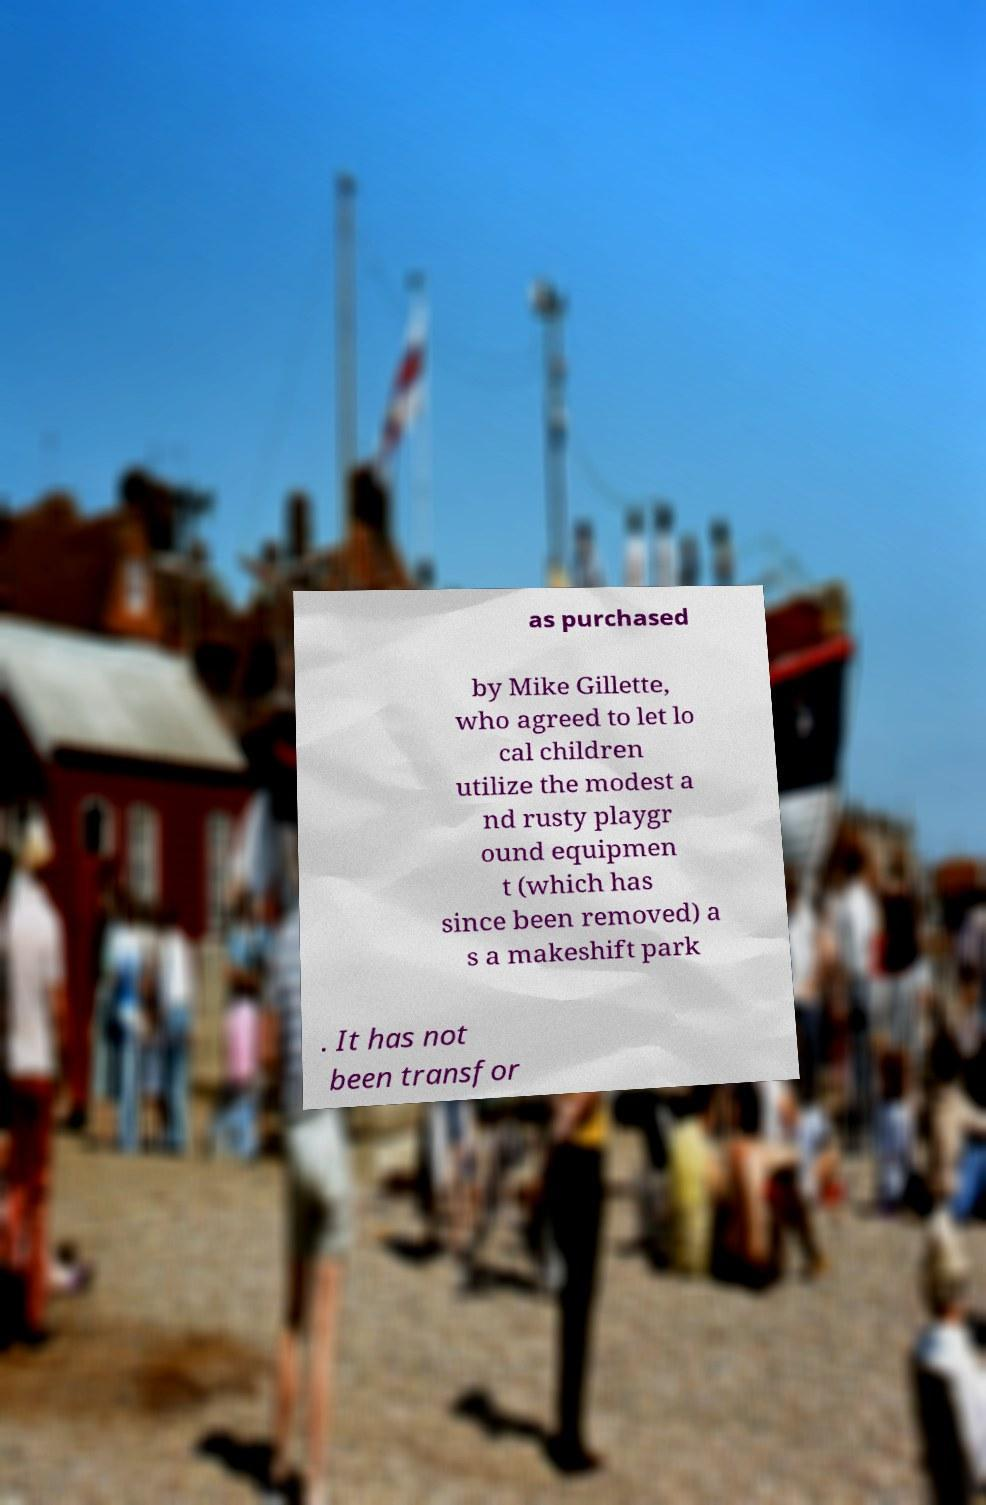Please read and relay the text visible in this image. What does it say? as purchased by Mike Gillette, who agreed to let lo cal children utilize the modest a nd rusty playgr ound equipmen t (which has since been removed) a s a makeshift park . It has not been transfor 